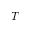<formula> <loc_0><loc_0><loc_500><loc_500>T</formula> 